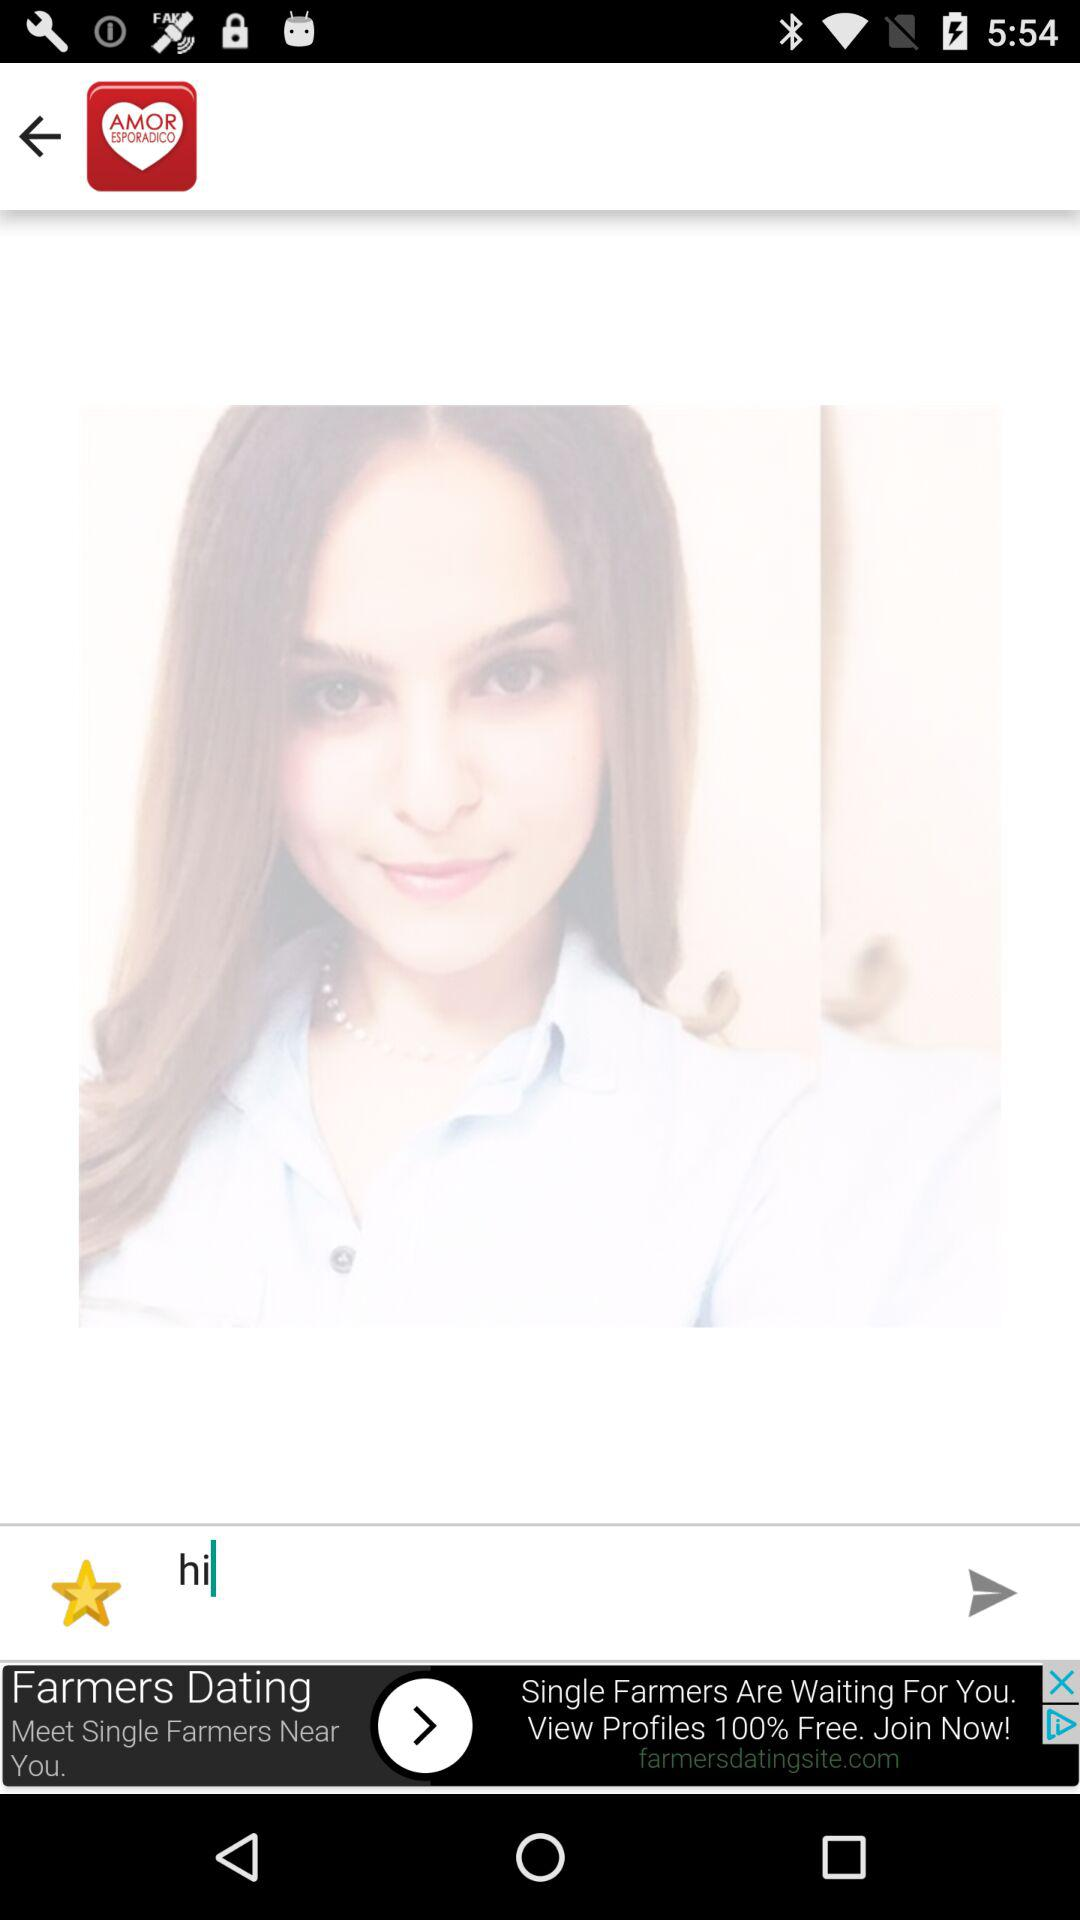What is the text shown in the text field? The shown text is "hi". 